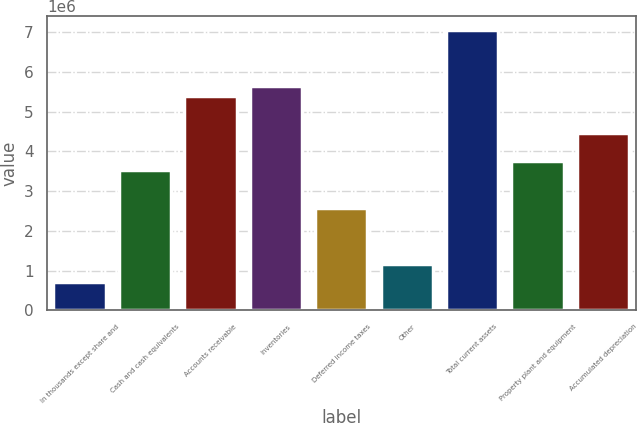Convert chart to OTSL. <chart><loc_0><loc_0><loc_500><loc_500><bar_chart><fcel>In thousands except share and<fcel>Cash and cash equivalents<fcel>Accounts receivable<fcel>Inventories<fcel>Deferred income taxes<fcel>Other<fcel>Total current assets<fcel>Property plant and equipment<fcel>Accumulated depreciation<nl><fcel>705493<fcel>3.52729e+06<fcel>5.40849e+06<fcel>5.64364e+06<fcel>2.58669e+06<fcel>1.17579e+06<fcel>7.05454e+06<fcel>3.76244e+06<fcel>4.46789e+06<nl></chart> 